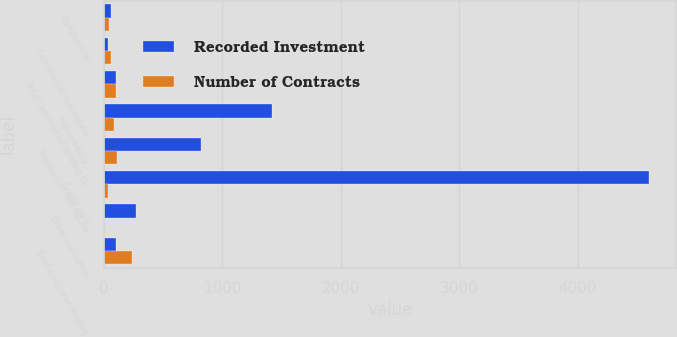<chart> <loc_0><loc_0><loc_500><loc_500><stacked_bar_chart><ecel><fcel>Commercial<fcel>Commercial real estate<fcel>Total commercial lending (a)<fcel>Home equity<fcel>Residential real estate<fcel>Credit card<fcel>Other consumer<fcel>Total consumer lending<nl><fcel>Recorded Investment<fcel>67<fcel>38<fcel>105<fcel>1420<fcel>824<fcel>4598<fcel>278<fcel>105<nl><fcel>Number of Contracts<fcel>47<fcel>59<fcel>106<fcel>89<fcel>115<fcel>34<fcel>4<fcel>242<nl></chart> 